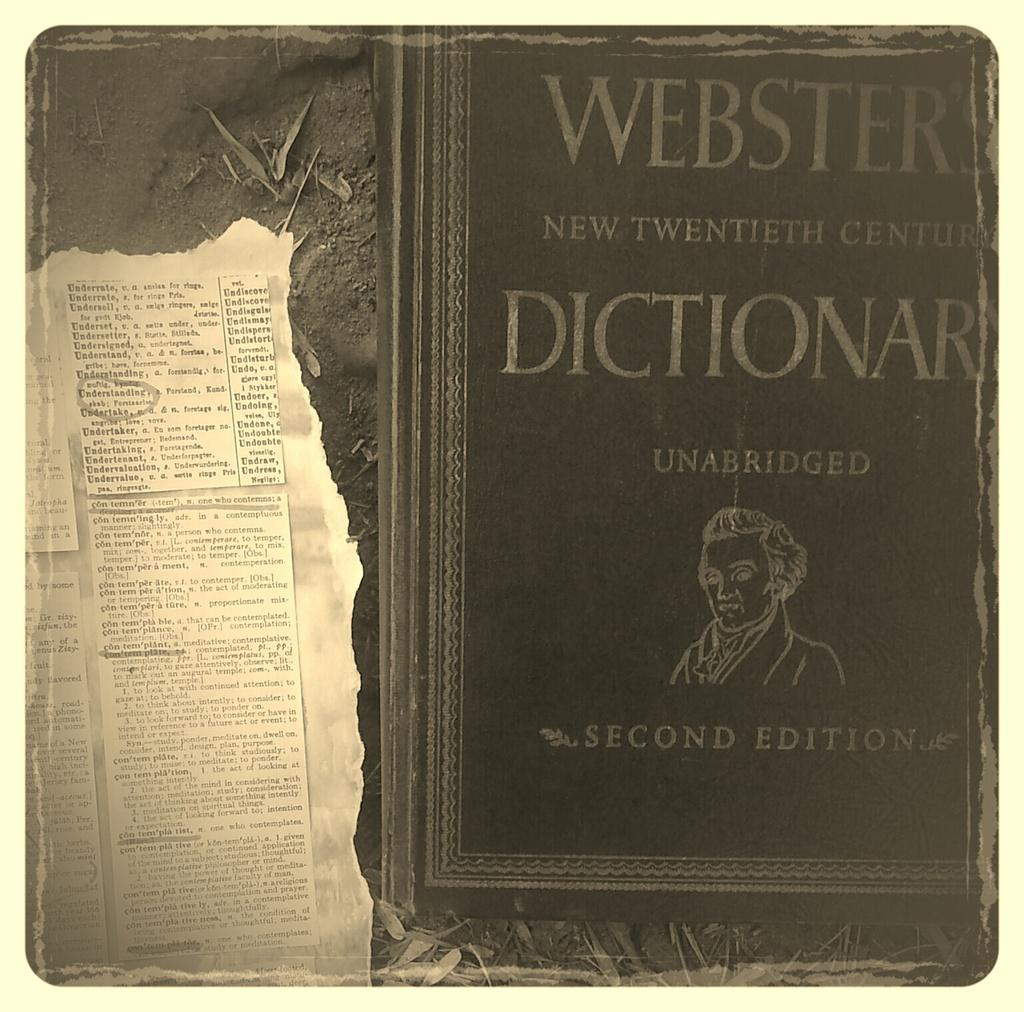<image>
Give a short and clear explanation of the subsequent image. A book called Websters New twentieth century dictionary second edition. 